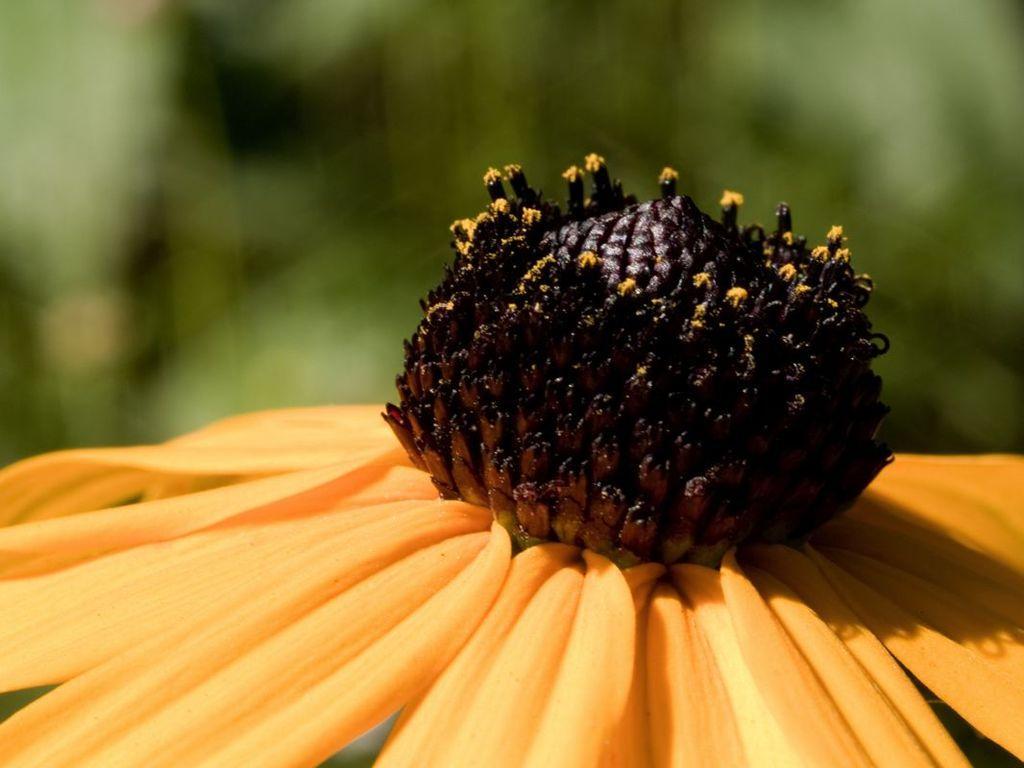In one or two sentences, can you explain what this image depicts? In this image at the bottom there is a flower and field. In the background there is greenery. 